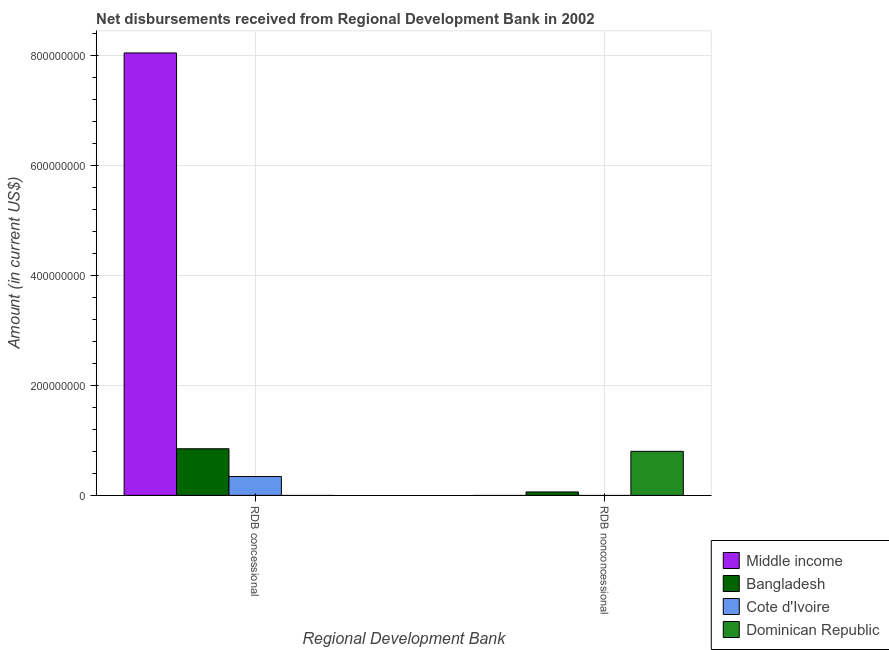How many groups of bars are there?
Provide a succinct answer. 2. Are the number of bars per tick equal to the number of legend labels?
Your response must be concise. No. How many bars are there on the 2nd tick from the left?
Provide a succinct answer. 2. How many bars are there on the 2nd tick from the right?
Your response must be concise. 3. What is the label of the 2nd group of bars from the left?
Your answer should be compact. RDB nonconcessional. What is the net non concessional disbursements from rdb in Bangladesh?
Provide a short and direct response. 6.25e+06. Across all countries, what is the maximum net concessional disbursements from rdb?
Your response must be concise. 8.05e+08. In which country was the net concessional disbursements from rdb maximum?
Make the answer very short. Middle income. What is the total net concessional disbursements from rdb in the graph?
Make the answer very short. 9.25e+08. What is the difference between the net concessional disbursements from rdb in Bangladesh and that in Cote d'Ivoire?
Provide a succinct answer. 5.06e+07. What is the difference between the net concessional disbursements from rdb in Bangladesh and the net non concessional disbursements from rdb in Cote d'Ivoire?
Offer a terse response. 8.49e+07. What is the average net non concessional disbursements from rdb per country?
Provide a short and direct response. 2.16e+07. What is the difference between the net non concessional disbursements from rdb and net concessional disbursements from rdb in Bangladesh?
Offer a very short reply. -7.86e+07. What is the ratio of the net concessional disbursements from rdb in Middle income to that in Bangladesh?
Your answer should be very brief. 9.49. In how many countries, is the net non concessional disbursements from rdb greater than the average net non concessional disbursements from rdb taken over all countries?
Offer a very short reply. 1. How many bars are there?
Your response must be concise. 5. Are the values on the major ticks of Y-axis written in scientific E-notation?
Your answer should be very brief. No. Does the graph contain grids?
Give a very brief answer. Yes. What is the title of the graph?
Make the answer very short. Net disbursements received from Regional Development Bank in 2002. Does "Uruguay" appear as one of the legend labels in the graph?
Keep it short and to the point. No. What is the label or title of the X-axis?
Offer a terse response. Regional Development Bank. What is the Amount (in current US$) of Middle income in RDB concessional?
Make the answer very short. 8.05e+08. What is the Amount (in current US$) of Bangladesh in RDB concessional?
Your answer should be compact. 8.49e+07. What is the Amount (in current US$) of Cote d'Ivoire in RDB concessional?
Your answer should be very brief. 3.43e+07. What is the Amount (in current US$) in Dominican Republic in RDB concessional?
Offer a very short reply. 0. What is the Amount (in current US$) in Middle income in RDB nonconcessional?
Ensure brevity in your answer.  0. What is the Amount (in current US$) in Bangladesh in RDB nonconcessional?
Your response must be concise. 6.25e+06. What is the Amount (in current US$) in Dominican Republic in RDB nonconcessional?
Your response must be concise. 8.02e+07. Across all Regional Development Bank, what is the maximum Amount (in current US$) of Middle income?
Your response must be concise. 8.05e+08. Across all Regional Development Bank, what is the maximum Amount (in current US$) in Bangladesh?
Provide a succinct answer. 8.49e+07. Across all Regional Development Bank, what is the maximum Amount (in current US$) in Cote d'Ivoire?
Keep it short and to the point. 3.43e+07. Across all Regional Development Bank, what is the maximum Amount (in current US$) of Dominican Republic?
Keep it short and to the point. 8.02e+07. Across all Regional Development Bank, what is the minimum Amount (in current US$) of Bangladesh?
Your answer should be very brief. 6.25e+06. Across all Regional Development Bank, what is the minimum Amount (in current US$) of Cote d'Ivoire?
Offer a very short reply. 0. Across all Regional Development Bank, what is the minimum Amount (in current US$) of Dominican Republic?
Provide a short and direct response. 0. What is the total Amount (in current US$) in Middle income in the graph?
Your response must be concise. 8.05e+08. What is the total Amount (in current US$) in Bangladesh in the graph?
Your answer should be very brief. 9.11e+07. What is the total Amount (in current US$) in Cote d'Ivoire in the graph?
Give a very brief answer. 3.43e+07. What is the total Amount (in current US$) of Dominican Republic in the graph?
Make the answer very short. 8.02e+07. What is the difference between the Amount (in current US$) of Bangladesh in RDB concessional and that in RDB nonconcessional?
Provide a succinct answer. 7.86e+07. What is the difference between the Amount (in current US$) in Middle income in RDB concessional and the Amount (in current US$) in Bangladesh in RDB nonconcessional?
Your answer should be very brief. 7.99e+08. What is the difference between the Amount (in current US$) of Middle income in RDB concessional and the Amount (in current US$) of Dominican Republic in RDB nonconcessional?
Keep it short and to the point. 7.25e+08. What is the difference between the Amount (in current US$) in Bangladesh in RDB concessional and the Amount (in current US$) in Dominican Republic in RDB nonconcessional?
Provide a short and direct response. 4.70e+06. What is the difference between the Amount (in current US$) in Cote d'Ivoire in RDB concessional and the Amount (in current US$) in Dominican Republic in RDB nonconcessional?
Offer a very short reply. -4.59e+07. What is the average Amount (in current US$) in Middle income per Regional Development Bank?
Give a very brief answer. 4.03e+08. What is the average Amount (in current US$) of Bangladesh per Regional Development Bank?
Your answer should be compact. 4.56e+07. What is the average Amount (in current US$) of Cote d'Ivoire per Regional Development Bank?
Your answer should be very brief. 1.71e+07. What is the average Amount (in current US$) in Dominican Republic per Regional Development Bank?
Make the answer very short. 4.01e+07. What is the difference between the Amount (in current US$) in Middle income and Amount (in current US$) in Bangladesh in RDB concessional?
Provide a short and direct response. 7.21e+08. What is the difference between the Amount (in current US$) in Middle income and Amount (in current US$) in Cote d'Ivoire in RDB concessional?
Offer a very short reply. 7.71e+08. What is the difference between the Amount (in current US$) in Bangladesh and Amount (in current US$) in Cote d'Ivoire in RDB concessional?
Your response must be concise. 5.06e+07. What is the difference between the Amount (in current US$) in Bangladesh and Amount (in current US$) in Dominican Republic in RDB nonconcessional?
Your answer should be very brief. -7.39e+07. What is the ratio of the Amount (in current US$) of Bangladesh in RDB concessional to that in RDB nonconcessional?
Provide a succinct answer. 13.58. What is the difference between the highest and the second highest Amount (in current US$) in Bangladesh?
Give a very brief answer. 7.86e+07. What is the difference between the highest and the lowest Amount (in current US$) of Middle income?
Your answer should be very brief. 8.05e+08. What is the difference between the highest and the lowest Amount (in current US$) in Bangladesh?
Make the answer very short. 7.86e+07. What is the difference between the highest and the lowest Amount (in current US$) of Cote d'Ivoire?
Offer a very short reply. 3.43e+07. What is the difference between the highest and the lowest Amount (in current US$) of Dominican Republic?
Ensure brevity in your answer.  8.02e+07. 